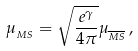Convert formula to latex. <formula><loc_0><loc_0><loc_500><loc_500>\mu _ { _ { M S } } = \sqrt { \frac { e ^ { \gamma } } { 4 \pi } } \mu _ { _ { \overline { M S } } } \, ,</formula> 